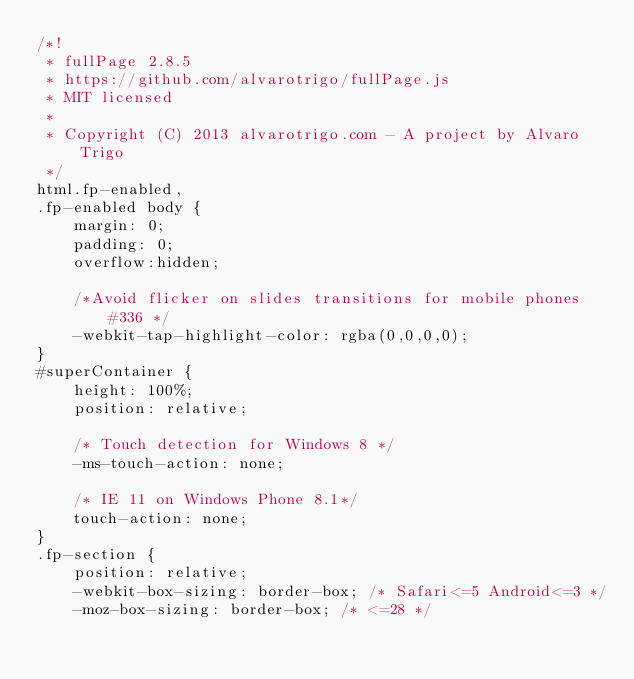Convert code to text. <code><loc_0><loc_0><loc_500><loc_500><_CSS_>/*!
 * fullPage 2.8.5
 * https://github.com/alvarotrigo/fullPage.js
 * MIT licensed
 *
 * Copyright (C) 2013 alvarotrigo.com - A project by Alvaro Trigo
 */
html.fp-enabled,
.fp-enabled body {
    margin: 0;
    padding: 0;
    overflow:hidden;

    /*Avoid flicker on slides transitions for mobile phones #336 */
    -webkit-tap-highlight-color: rgba(0,0,0,0);
}
#superContainer {
    height: 100%;
    position: relative;

    /* Touch detection for Windows 8 */
    -ms-touch-action: none;

    /* IE 11 on Windows Phone 8.1*/
    touch-action: none;
}
.fp-section {
    position: relative;
    -webkit-box-sizing: border-box; /* Safari<=5 Android<=3 */
    -moz-box-sizing: border-box; /* <=28 */</code> 